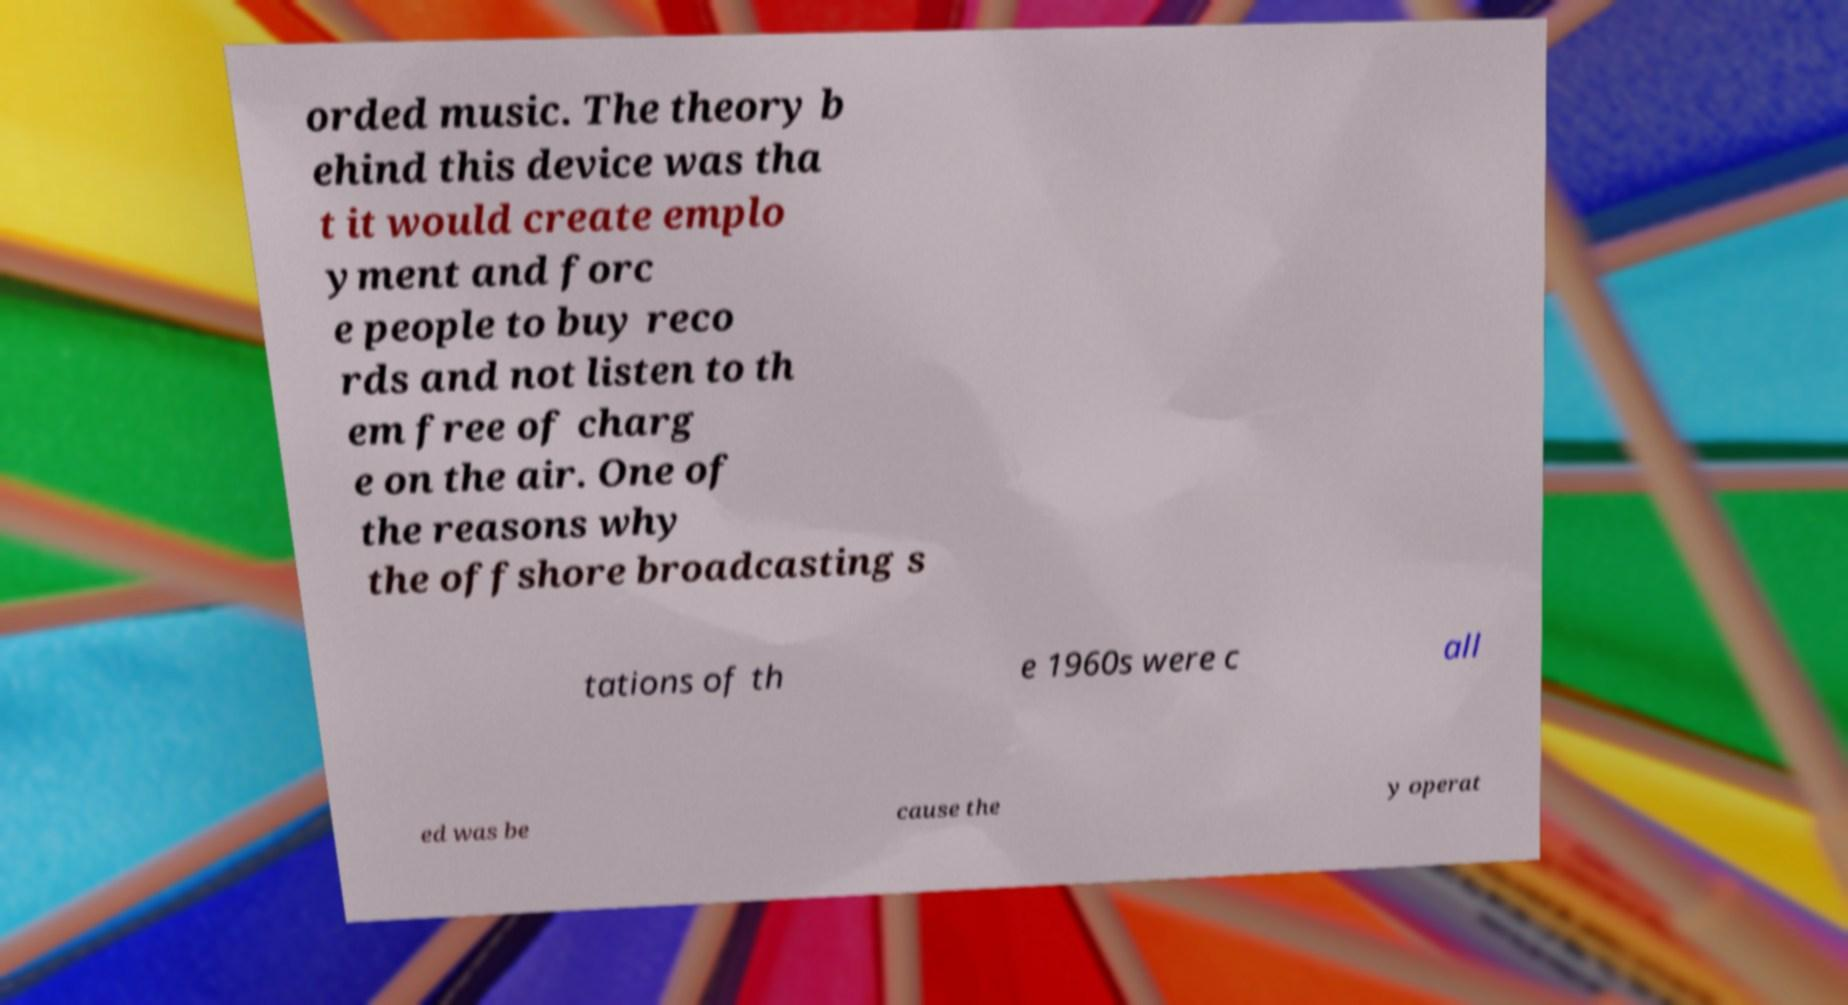Please identify and transcribe the text found in this image. orded music. The theory b ehind this device was tha t it would create emplo yment and forc e people to buy reco rds and not listen to th em free of charg e on the air. One of the reasons why the offshore broadcasting s tations of th e 1960s were c all ed was be cause the y operat 